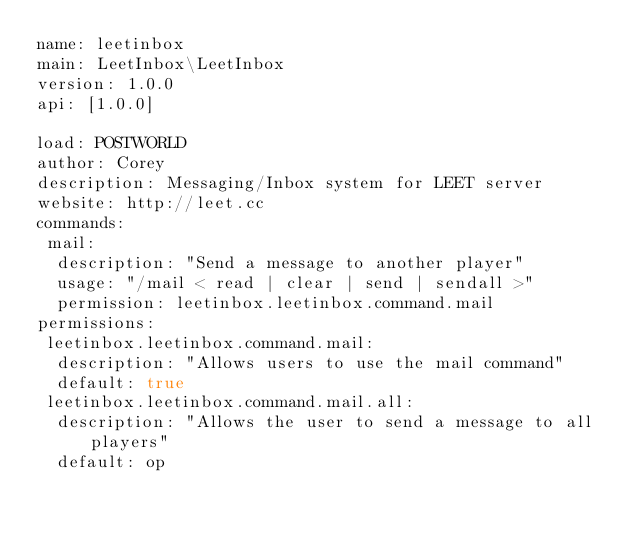Convert code to text. <code><loc_0><loc_0><loc_500><loc_500><_YAML_>name: leetinbox
main: LeetInbox\LeetInbox
version: 1.0.0
api: [1.0.0]

load: POSTWORLD
author: Corey
description: Messaging/Inbox system for LEET server
website: http://leet.cc
commands:
 mail:
  description: "Send a message to another player"
  usage: "/mail < read | clear | send | sendall >"
  permission: leetinbox.leetinbox.command.mail
permissions:
 leetinbox.leetinbox.command.mail:
  description: "Allows users to use the mail command"
  default: true
 leetinbox.leetinbox.command.mail.all:
  description: "Allows the user to send a message to all players"
  default: op
</code> 